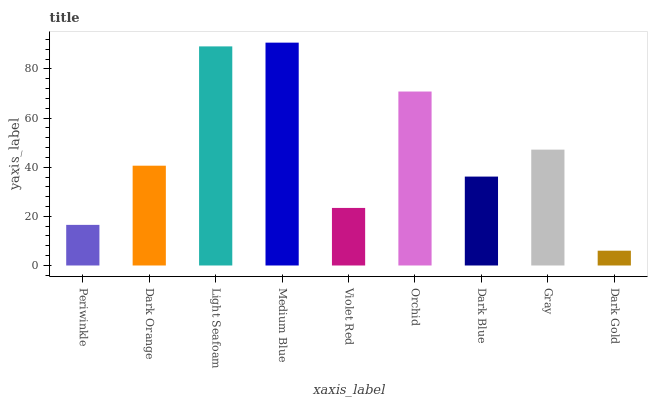Is Dark Orange the minimum?
Answer yes or no. No. Is Dark Orange the maximum?
Answer yes or no. No. Is Dark Orange greater than Periwinkle?
Answer yes or no. Yes. Is Periwinkle less than Dark Orange?
Answer yes or no. Yes. Is Periwinkle greater than Dark Orange?
Answer yes or no. No. Is Dark Orange less than Periwinkle?
Answer yes or no. No. Is Dark Orange the high median?
Answer yes or no. Yes. Is Dark Orange the low median?
Answer yes or no. Yes. Is Orchid the high median?
Answer yes or no. No. Is Dark Gold the low median?
Answer yes or no. No. 